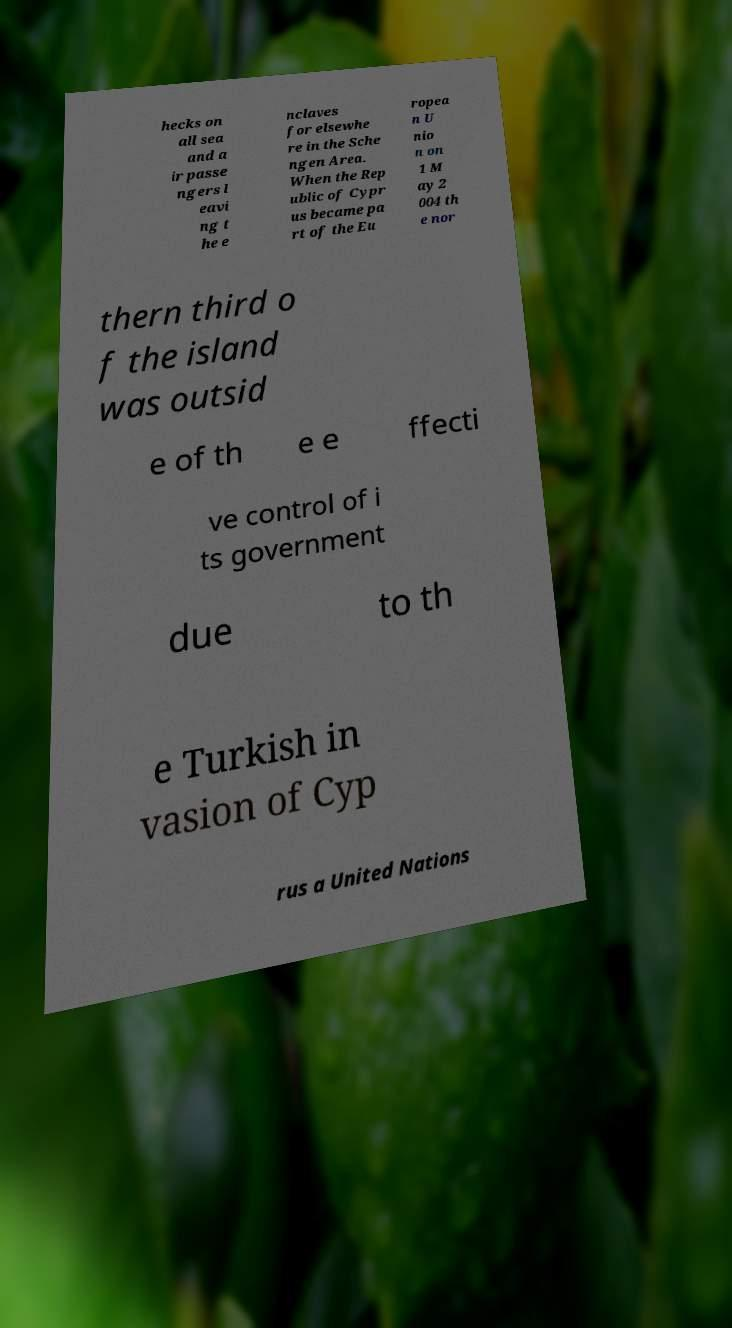Could you assist in decoding the text presented in this image and type it out clearly? hecks on all sea and a ir passe ngers l eavi ng t he e nclaves for elsewhe re in the Sche ngen Area. When the Rep ublic of Cypr us became pa rt of the Eu ropea n U nio n on 1 M ay 2 004 th e nor thern third o f the island was outsid e of th e e ffecti ve control of i ts government due to th e Turkish in vasion of Cyp rus a United Nations 